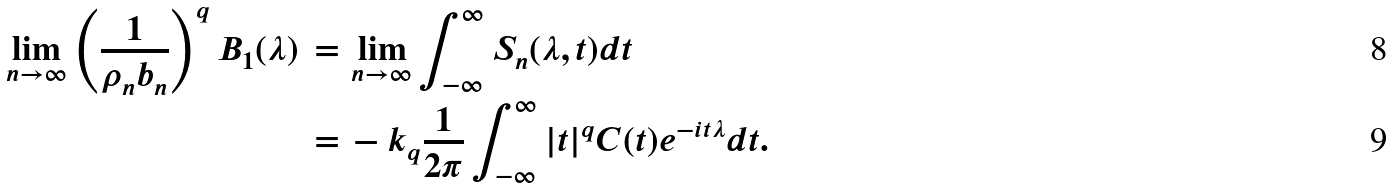Convert formula to latex. <formula><loc_0><loc_0><loc_500><loc_500>\lim _ { n \rightarrow \infty } \left ( \frac { 1 } { \rho _ { n } b _ { n } } \right ) ^ { q } B _ { 1 } ( \lambda ) \, = \, & \lim _ { n \rightarrow \infty } \int _ { - \infty } ^ { \infty } S _ { n } ( \lambda , t ) d t \\ \, = \, & - k _ { q } \frac { 1 } { 2 \pi } \int _ { - \infty } ^ { \infty } | t | ^ { q } C ( t ) e ^ { - i t \lambda } d t .</formula> 